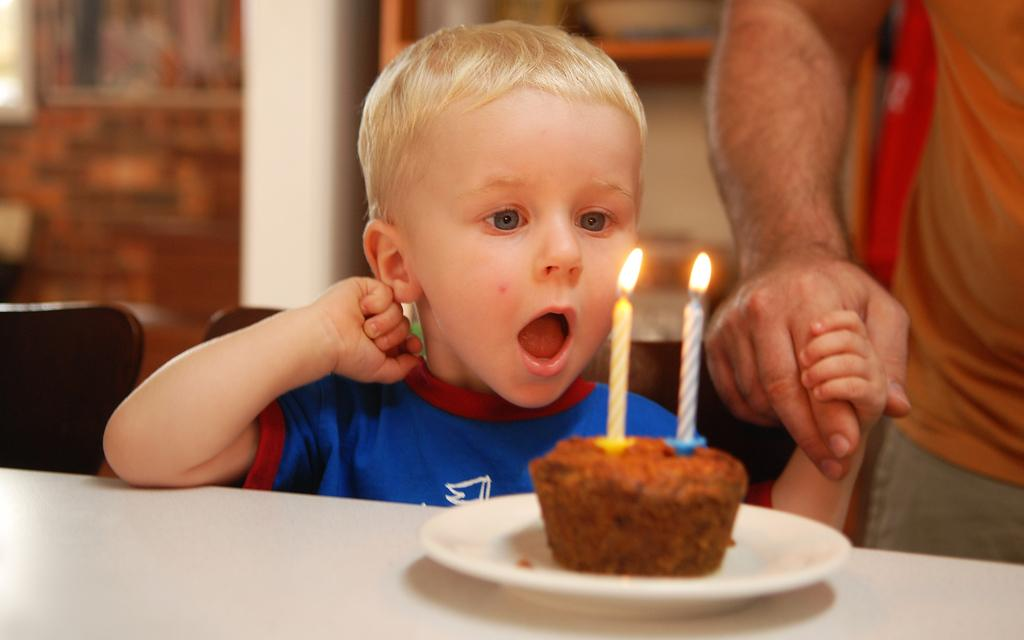Who is present in the image? There is a child and a person in the image. What is the child doing in the image? The information provided does not specify what the child is doing. What is on the table in the image? There is a serving plate on the table. What is on the serving plate? The serving plate contains cake. What is special about the cake on the serving plate? The cake has candles on it. What type of brain is visible on the cake in the image? There is no brain visible on the cake in the image; it only has candles. What attraction can be seen in the background of the image? The information provided does not mention any attractions in the background of the image. 